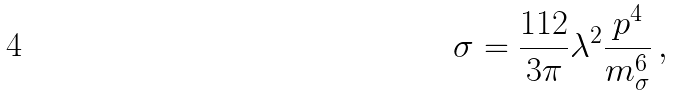<formula> <loc_0><loc_0><loc_500><loc_500>\sigma = \frac { 1 1 2 } { 3 \pi } \lambda ^ { 2 } \frac { p ^ { 4 } } { m _ { \sigma } ^ { 6 } } \, ,</formula> 